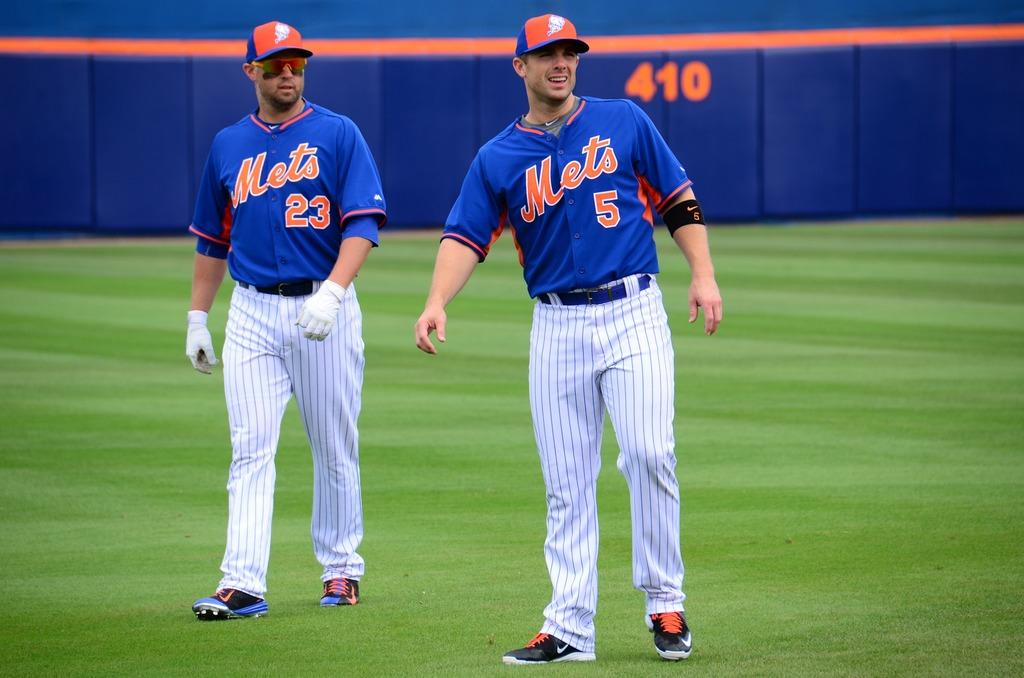<image>
Summarize the visual content of the image. Mets players 5 and 23 walk across the outfield. 